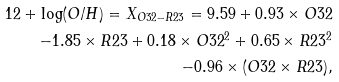<formula> <loc_0><loc_0><loc_500><loc_500>1 2 + \log ( O / H ) = X _ { O 3 2 - R 2 3 } = 9 . 5 9 + 0 . 9 3 \times O 3 2 \\ - 1 . 8 5 \times R 2 3 + 0 . 1 8 \times O 3 2 ^ { 2 } + 0 . 6 5 \times R 2 3 ^ { 2 } \\ - 0 . 9 6 \times ( O 3 2 \times R 2 3 ) ,</formula> 